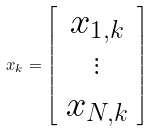Convert formula to latex. <formula><loc_0><loc_0><loc_500><loc_500>x _ { k } = \left [ \begin{array} { c } x _ { 1 , k } \\ \vdots \\ x _ { N , k } \end{array} \right ]</formula> 